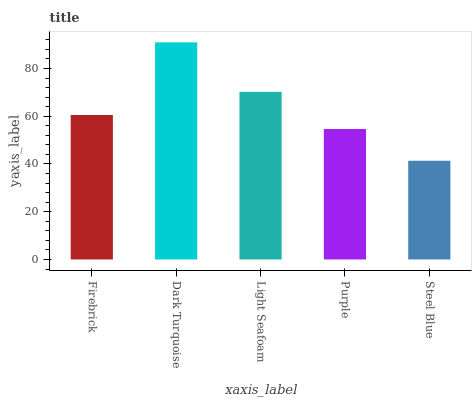Is Steel Blue the minimum?
Answer yes or no. Yes. Is Dark Turquoise the maximum?
Answer yes or no. Yes. Is Light Seafoam the minimum?
Answer yes or no. No. Is Light Seafoam the maximum?
Answer yes or no. No. Is Dark Turquoise greater than Light Seafoam?
Answer yes or no. Yes. Is Light Seafoam less than Dark Turquoise?
Answer yes or no. Yes. Is Light Seafoam greater than Dark Turquoise?
Answer yes or no. No. Is Dark Turquoise less than Light Seafoam?
Answer yes or no. No. Is Firebrick the high median?
Answer yes or no. Yes. Is Firebrick the low median?
Answer yes or no. Yes. Is Steel Blue the high median?
Answer yes or no. No. Is Steel Blue the low median?
Answer yes or no. No. 